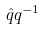Convert formula to latex. <formula><loc_0><loc_0><loc_500><loc_500>\hat { q } q ^ { - 1 }</formula> 